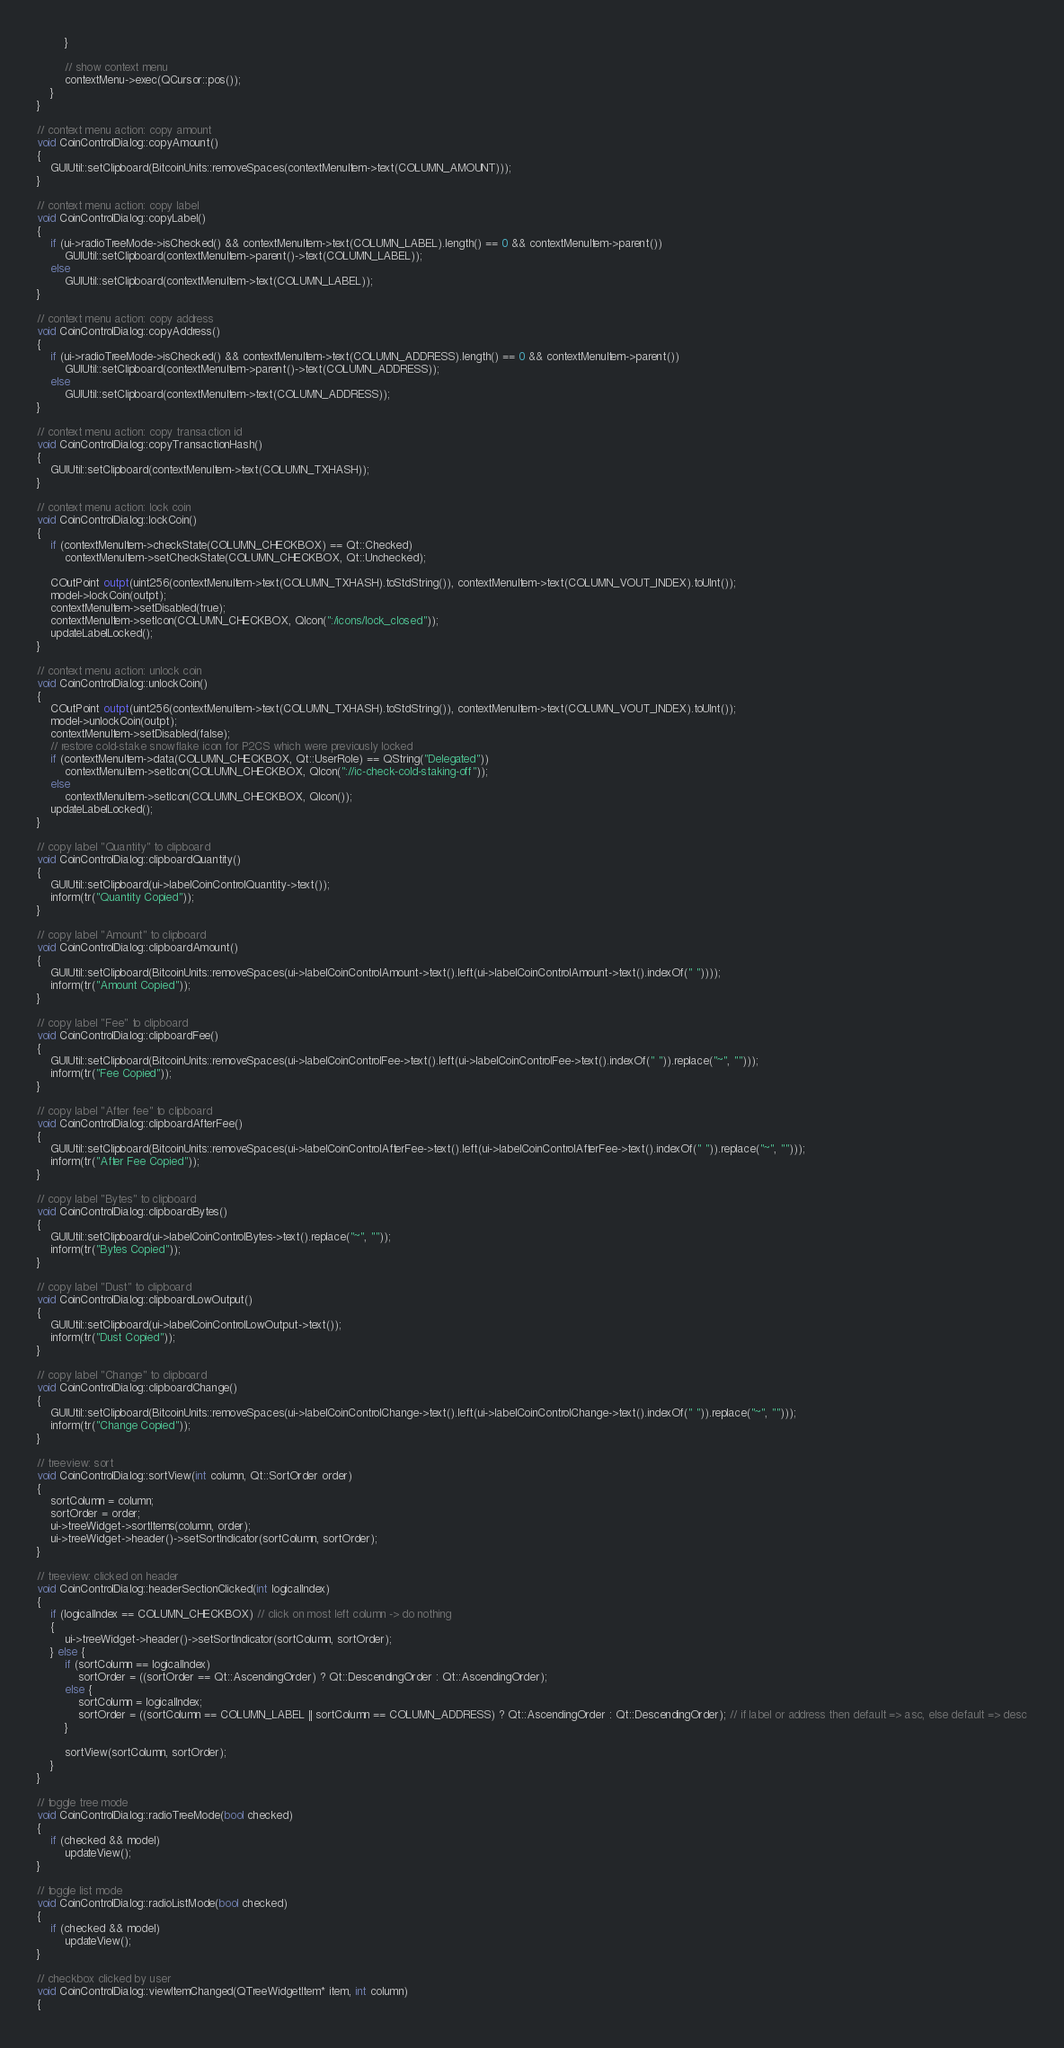Convert code to text. <code><loc_0><loc_0><loc_500><loc_500><_C++_>        }

        // show context menu
        contextMenu->exec(QCursor::pos());
    }
}

// context menu action: copy amount
void CoinControlDialog::copyAmount()
{
    GUIUtil::setClipboard(BitcoinUnits::removeSpaces(contextMenuItem->text(COLUMN_AMOUNT)));
}

// context menu action: copy label
void CoinControlDialog::copyLabel()
{
    if (ui->radioTreeMode->isChecked() && contextMenuItem->text(COLUMN_LABEL).length() == 0 && contextMenuItem->parent())
        GUIUtil::setClipboard(contextMenuItem->parent()->text(COLUMN_LABEL));
    else
        GUIUtil::setClipboard(contextMenuItem->text(COLUMN_LABEL));
}

// context menu action: copy address
void CoinControlDialog::copyAddress()
{
    if (ui->radioTreeMode->isChecked() && contextMenuItem->text(COLUMN_ADDRESS).length() == 0 && contextMenuItem->parent())
        GUIUtil::setClipboard(contextMenuItem->parent()->text(COLUMN_ADDRESS));
    else
        GUIUtil::setClipboard(contextMenuItem->text(COLUMN_ADDRESS));
}

// context menu action: copy transaction id
void CoinControlDialog::copyTransactionHash()
{
    GUIUtil::setClipboard(contextMenuItem->text(COLUMN_TXHASH));
}

// context menu action: lock coin
void CoinControlDialog::lockCoin()
{
    if (contextMenuItem->checkState(COLUMN_CHECKBOX) == Qt::Checked)
        contextMenuItem->setCheckState(COLUMN_CHECKBOX, Qt::Unchecked);

    COutPoint outpt(uint256(contextMenuItem->text(COLUMN_TXHASH).toStdString()), contextMenuItem->text(COLUMN_VOUT_INDEX).toUInt());
    model->lockCoin(outpt);
    contextMenuItem->setDisabled(true);
    contextMenuItem->setIcon(COLUMN_CHECKBOX, QIcon(":/icons/lock_closed"));
    updateLabelLocked();
}

// context menu action: unlock coin
void CoinControlDialog::unlockCoin()
{
    COutPoint outpt(uint256(contextMenuItem->text(COLUMN_TXHASH).toStdString()), contextMenuItem->text(COLUMN_VOUT_INDEX).toUInt());
    model->unlockCoin(outpt);
    contextMenuItem->setDisabled(false);
    // restore cold-stake snowflake icon for P2CS which were previously locked
    if (contextMenuItem->data(COLUMN_CHECKBOX, Qt::UserRole) == QString("Delegated"))
        contextMenuItem->setIcon(COLUMN_CHECKBOX, QIcon("://ic-check-cold-staking-off"));
    else
        contextMenuItem->setIcon(COLUMN_CHECKBOX, QIcon());
    updateLabelLocked();
}

// copy label "Quantity" to clipboard
void CoinControlDialog::clipboardQuantity()
{
    GUIUtil::setClipboard(ui->labelCoinControlQuantity->text());
    inform(tr("Quantity Copied"));
}

// copy label "Amount" to clipboard
void CoinControlDialog::clipboardAmount()
{
    GUIUtil::setClipboard(BitcoinUnits::removeSpaces(ui->labelCoinControlAmount->text().left(ui->labelCoinControlAmount->text().indexOf(" "))));
    inform(tr("Amount Copied"));
}

// copy label "Fee" to clipboard
void CoinControlDialog::clipboardFee()
{
    GUIUtil::setClipboard(BitcoinUnits::removeSpaces(ui->labelCoinControlFee->text().left(ui->labelCoinControlFee->text().indexOf(" ")).replace("~", "")));
    inform(tr("Fee Copied"));
}

// copy label "After fee" to clipboard
void CoinControlDialog::clipboardAfterFee()
{
    GUIUtil::setClipboard(BitcoinUnits::removeSpaces(ui->labelCoinControlAfterFee->text().left(ui->labelCoinControlAfterFee->text().indexOf(" ")).replace("~", "")));
    inform(tr("After Fee Copied"));
}

// copy label "Bytes" to clipboard
void CoinControlDialog::clipboardBytes()
{
    GUIUtil::setClipboard(ui->labelCoinControlBytes->text().replace("~", ""));
    inform(tr("Bytes Copied"));
}

// copy label "Dust" to clipboard
void CoinControlDialog::clipboardLowOutput()
{
    GUIUtil::setClipboard(ui->labelCoinControlLowOutput->text());
    inform(tr("Dust Copied"));
}

// copy label "Change" to clipboard
void CoinControlDialog::clipboardChange()
{
    GUIUtil::setClipboard(BitcoinUnits::removeSpaces(ui->labelCoinControlChange->text().left(ui->labelCoinControlChange->text().indexOf(" ")).replace("~", "")));
    inform(tr("Change Copied"));
}

// treeview: sort
void CoinControlDialog::sortView(int column, Qt::SortOrder order)
{
    sortColumn = column;
    sortOrder = order;
    ui->treeWidget->sortItems(column, order);
    ui->treeWidget->header()->setSortIndicator(sortColumn, sortOrder);
}

// treeview: clicked on header
void CoinControlDialog::headerSectionClicked(int logicalIndex)
{
    if (logicalIndex == COLUMN_CHECKBOX) // click on most left column -> do nothing
    {
        ui->treeWidget->header()->setSortIndicator(sortColumn, sortOrder);
    } else {
        if (sortColumn == logicalIndex)
            sortOrder = ((sortOrder == Qt::AscendingOrder) ? Qt::DescendingOrder : Qt::AscendingOrder);
        else {
            sortColumn = logicalIndex;
            sortOrder = ((sortColumn == COLUMN_LABEL || sortColumn == COLUMN_ADDRESS) ? Qt::AscendingOrder : Qt::DescendingOrder); // if label or address then default => asc, else default => desc
        }

        sortView(sortColumn, sortOrder);
    }
}

// toggle tree mode
void CoinControlDialog::radioTreeMode(bool checked)
{
    if (checked && model)
        updateView();
}

// toggle list mode
void CoinControlDialog::radioListMode(bool checked)
{
    if (checked && model)
        updateView();
}

// checkbox clicked by user
void CoinControlDialog::viewItemChanged(QTreeWidgetItem* item, int column)
{</code> 